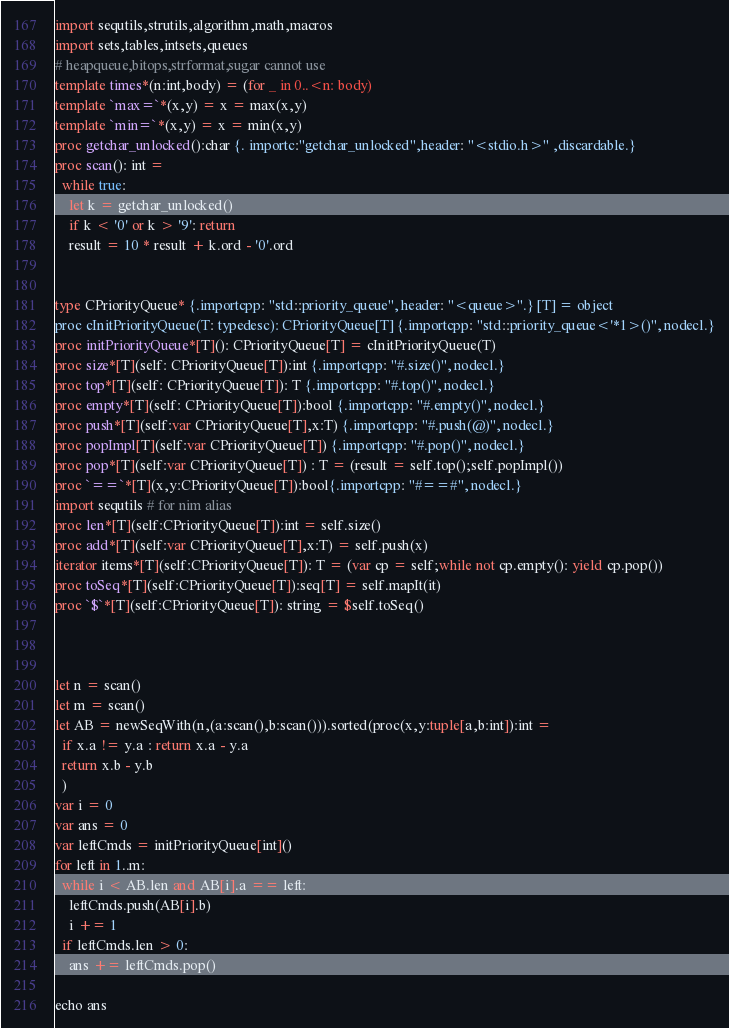<code> <loc_0><loc_0><loc_500><loc_500><_Nim_>import sequtils,strutils,algorithm,math,macros
import sets,tables,intsets,queues
# heapqueue,bitops,strformat,sugar cannot use
template times*(n:int,body) = (for _ in 0..<n: body)
template `max=`*(x,y) = x = max(x,y)
template `min=`*(x,y) = x = min(x,y)
proc getchar_unlocked():char {. importc:"getchar_unlocked",header: "<stdio.h>" ,discardable.}
proc scan(): int =
  while true:
    let k = getchar_unlocked()
    if k < '0' or k > '9': return
    result = 10 * result + k.ord - '0'.ord


type CPriorityQueue* {.importcpp: "std::priority_queue", header: "<queue>".} [T] = object
proc cInitPriorityQueue(T: typedesc): CPriorityQueue[T] {.importcpp: "std::priority_queue<'*1>()", nodecl.}
proc initPriorityQueue*[T](): CPriorityQueue[T] = cInitPriorityQueue(T)
proc size*[T](self: CPriorityQueue[T]):int {.importcpp: "#.size()", nodecl.}
proc top*[T](self: CPriorityQueue[T]): T {.importcpp: "#.top()", nodecl.}
proc empty*[T](self: CPriorityQueue[T]):bool {.importcpp: "#.empty()", nodecl.}
proc push*[T](self:var CPriorityQueue[T],x:T) {.importcpp: "#.push(@)", nodecl.}
proc popImpl[T](self:var CPriorityQueue[T]) {.importcpp: "#.pop()", nodecl.}
proc pop*[T](self:var CPriorityQueue[T]) : T = (result = self.top();self.popImpl())
proc `==`*[T](x,y:CPriorityQueue[T]):bool{.importcpp: "#==#", nodecl.}
import sequtils # for nim alias
proc len*[T](self:CPriorityQueue[T]):int = self.size()
proc add*[T](self:var CPriorityQueue[T],x:T) = self.push(x)
iterator items*[T](self:CPriorityQueue[T]): T = (var cp = self;while not cp.empty(): yield cp.pop())
proc toSeq*[T](self:CPriorityQueue[T]):seq[T] = self.mapIt(it)
proc `$`*[T](self:CPriorityQueue[T]): string = $self.toSeq()



let n = scan()
let m = scan()
let AB = newSeqWith(n,(a:scan(),b:scan())).sorted(proc(x,y:tuple[a,b:int]):int =
  if x.a != y.a : return x.a - y.a
  return x.b - y.b
  )
var i = 0
var ans = 0
var leftCmds = initPriorityQueue[int]()
for left in 1..m:
  while i < AB.len and AB[i].a == left:
    leftCmds.push(AB[i].b)
    i += 1
  if leftCmds.len > 0:
    ans += leftCmds.pop()

echo ans
</code> 